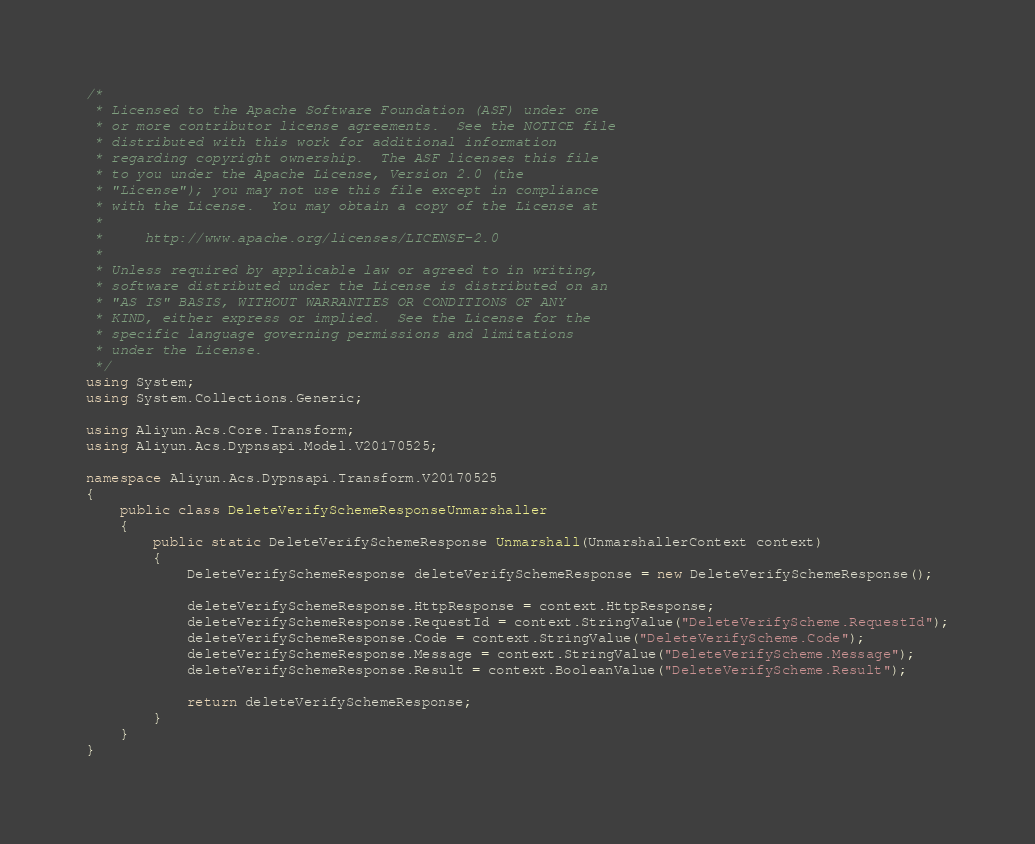<code> <loc_0><loc_0><loc_500><loc_500><_C#_>/*
 * Licensed to the Apache Software Foundation (ASF) under one
 * or more contributor license agreements.  See the NOTICE file
 * distributed with this work for additional information
 * regarding copyright ownership.  The ASF licenses this file
 * to you under the Apache License, Version 2.0 (the
 * "License"); you may not use this file except in compliance
 * with the License.  You may obtain a copy of the License at
 *
 *     http://www.apache.org/licenses/LICENSE-2.0
 *
 * Unless required by applicable law or agreed to in writing,
 * software distributed under the License is distributed on an
 * "AS IS" BASIS, WITHOUT WARRANTIES OR CONDITIONS OF ANY
 * KIND, either express or implied.  See the License for the
 * specific language governing permissions and limitations
 * under the License.
 */
using System;
using System.Collections.Generic;

using Aliyun.Acs.Core.Transform;
using Aliyun.Acs.Dypnsapi.Model.V20170525;

namespace Aliyun.Acs.Dypnsapi.Transform.V20170525
{
    public class DeleteVerifySchemeResponseUnmarshaller
    {
        public static DeleteVerifySchemeResponse Unmarshall(UnmarshallerContext context)
        {
			DeleteVerifySchemeResponse deleteVerifySchemeResponse = new DeleteVerifySchemeResponse();

			deleteVerifySchemeResponse.HttpResponse = context.HttpResponse;
			deleteVerifySchemeResponse.RequestId = context.StringValue("DeleteVerifyScheme.RequestId");
			deleteVerifySchemeResponse.Code = context.StringValue("DeleteVerifyScheme.Code");
			deleteVerifySchemeResponse.Message = context.StringValue("DeleteVerifyScheme.Message");
			deleteVerifySchemeResponse.Result = context.BooleanValue("DeleteVerifyScheme.Result");
        
			return deleteVerifySchemeResponse;
        }
    }
}
</code> 